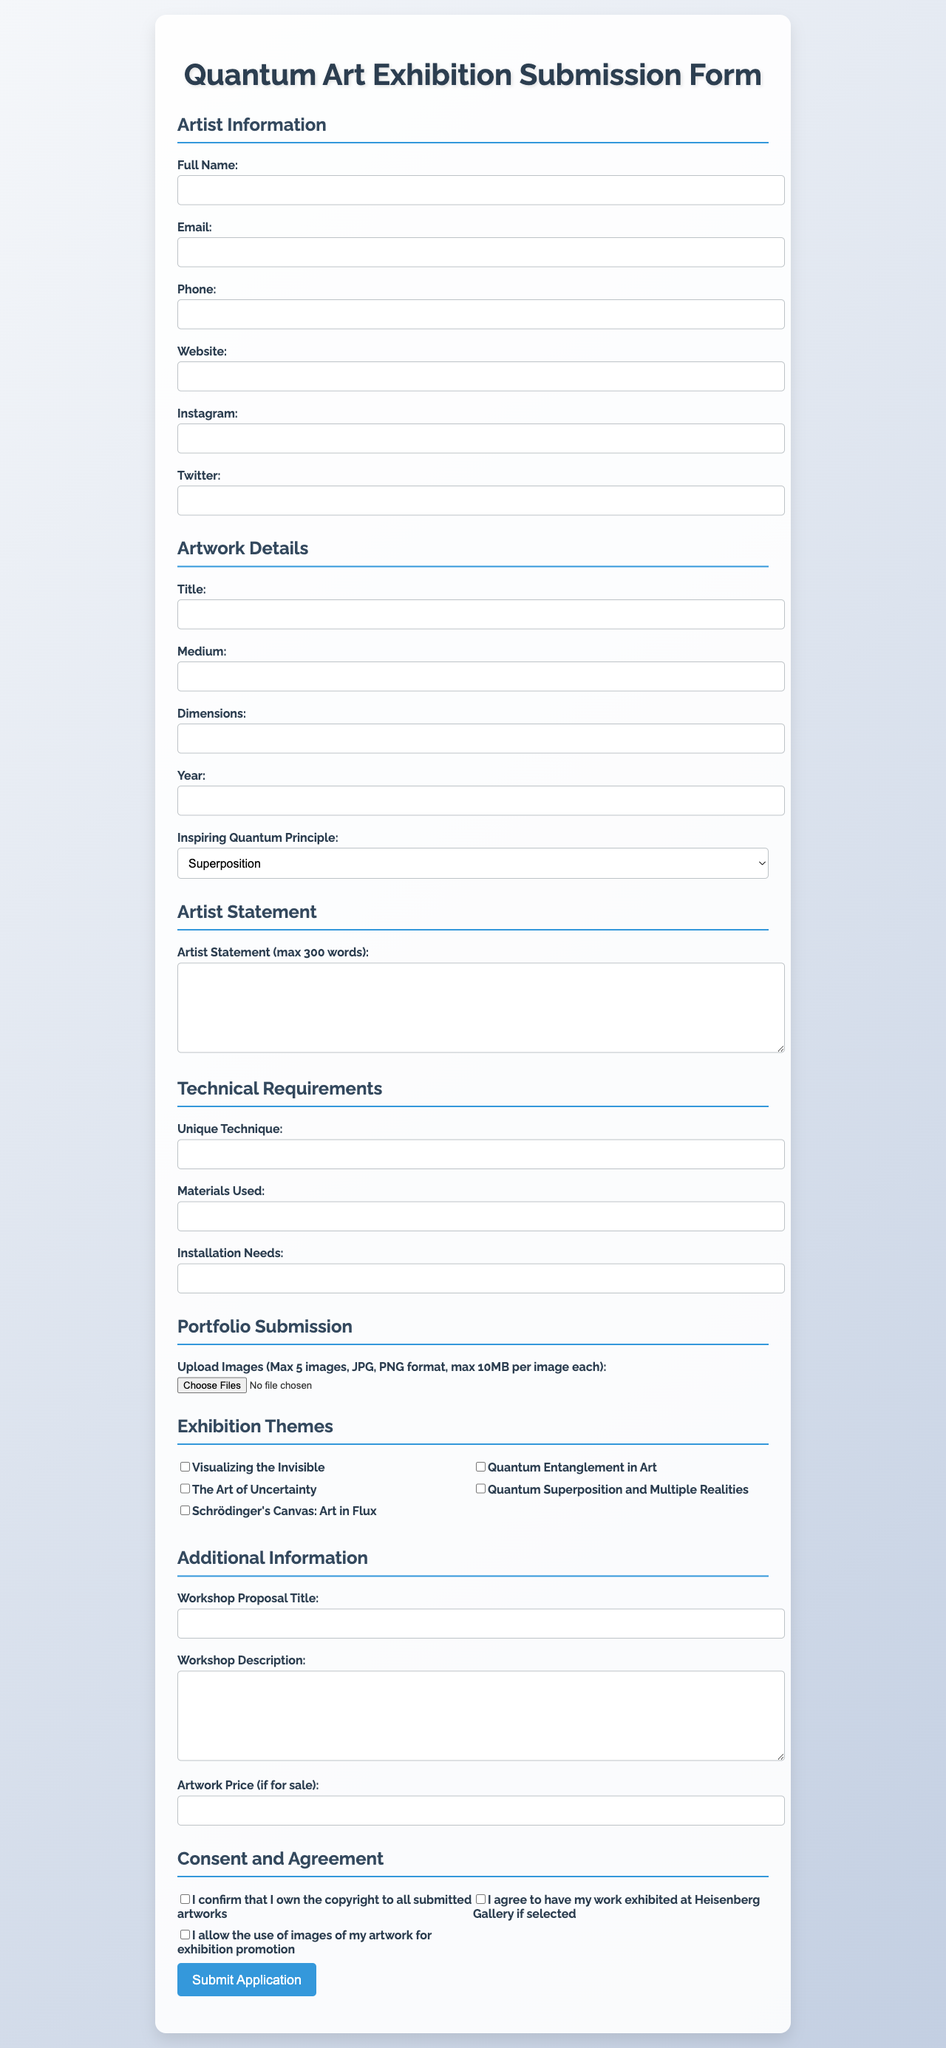What is the title of the exhibition? The title of the exhibition is explicitly mentioned in the document, stating "Quantum Visions: Art Inspired by the Microscopic World."
Answer: Quantum Visions: Art Inspired by the Microscopic World When is the submission deadline? The submission deadline is provided as a specific date in the document, which is September 30, 2023.
Answer: September 30, 2023 How many maximum images can be submitted in the portfolio? The maximum number of images that can be submitted is clearly stated within the guidelines of the form as five.
Answer: 5 What is the gallery's commission percentage on artwork sales? The document specifies the commission percentage that the gallery will take from sales, which is thirty percent.
Answer: 30% What are the exhibition dates? The exhibition dates are outlined in the document as the period from November 15, 2023, to February 28, 2024.
Answer: November 15, 2023 - February 28, 2024 What is the maximum word limit for the artist statement? The document indicates the maximum word count allowed for the artist statement as three hundred words.
Answer: 300 Which principle is not listed under the inspiring quantum principles? The choices given for inspiring quantum principles are listed in the document, and any principle not among them can be identified.
Answer: None What type of artists can submit their work? The eligibility criteria in the document mention that both professional and emerging artists are welcome to submit their work.
Answer: Professional and emerging artists What is required for the consent regarding copyright? The document contains a statement that requires confirmation of ownership of the copyright to submitted artworks.
Answer: I confirm that I own the copyright to all submitted artworks 